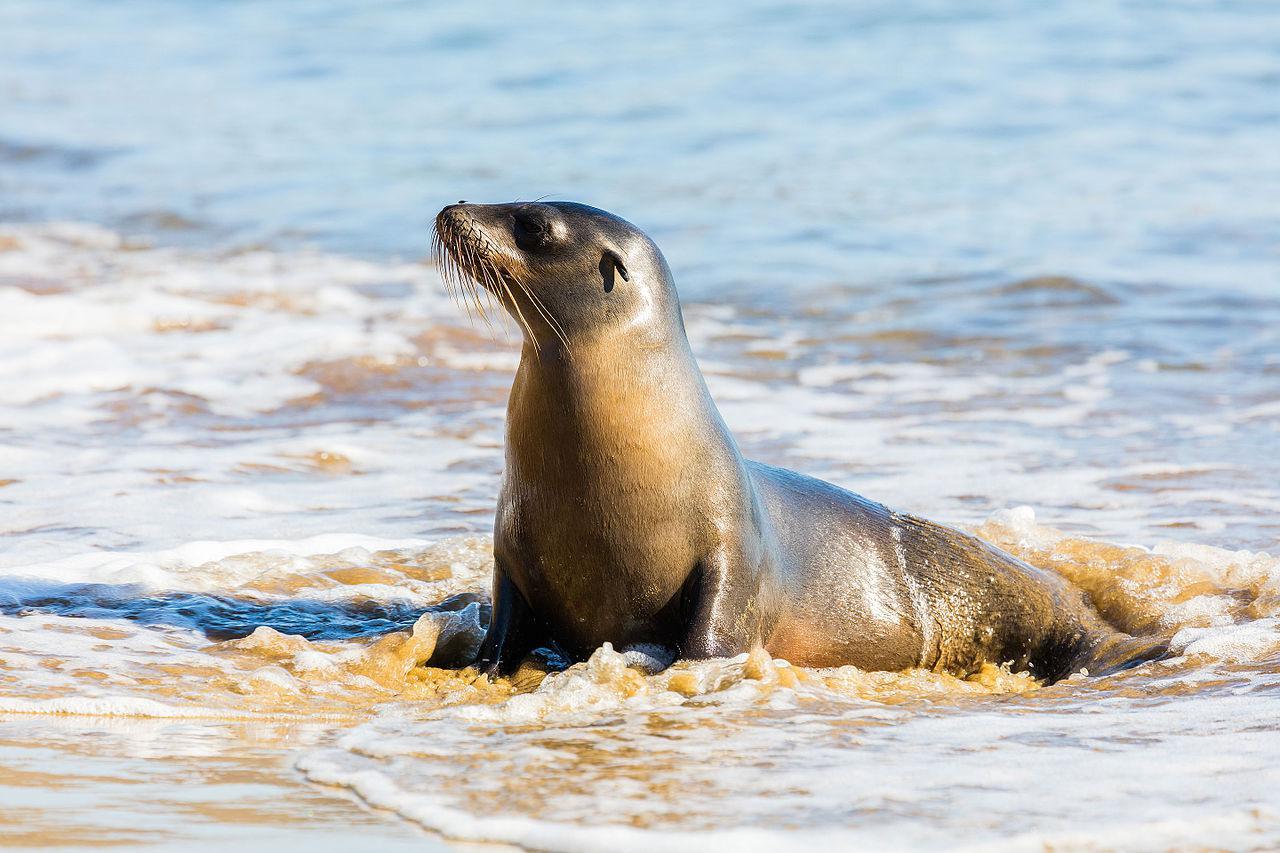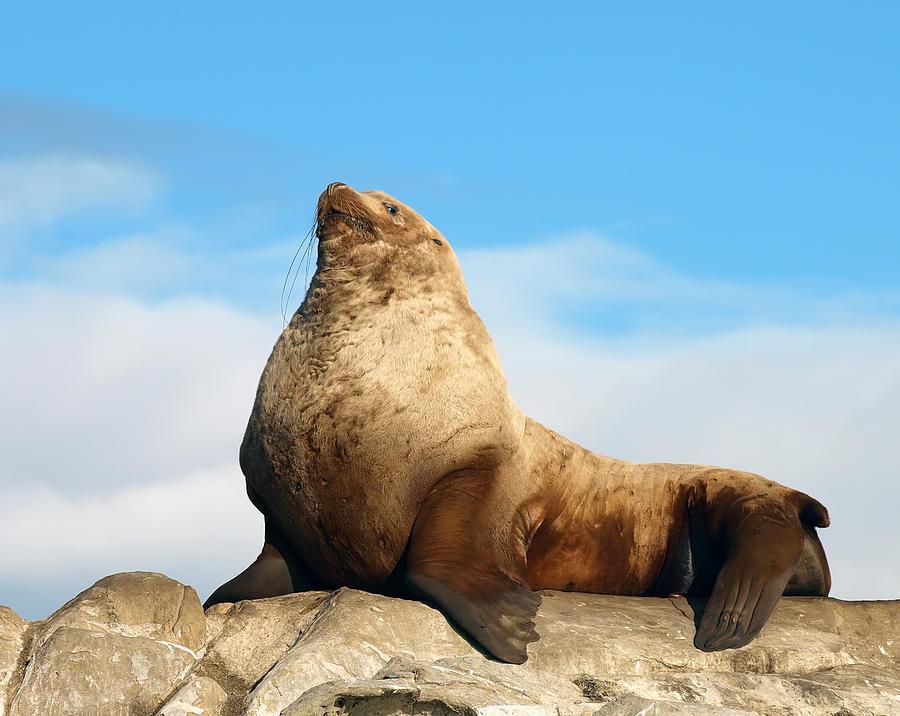The first image is the image on the left, the second image is the image on the right. Examine the images to the left and right. Is the description "Both of the seals are looking to the left of the image." accurate? Answer yes or no. Yes. The first image is the image on the left, the second image is the image on the right. Analyze the images presented: Is the assertion "There are two sea lions facing left." valid? Answer yes or no. Yes. 